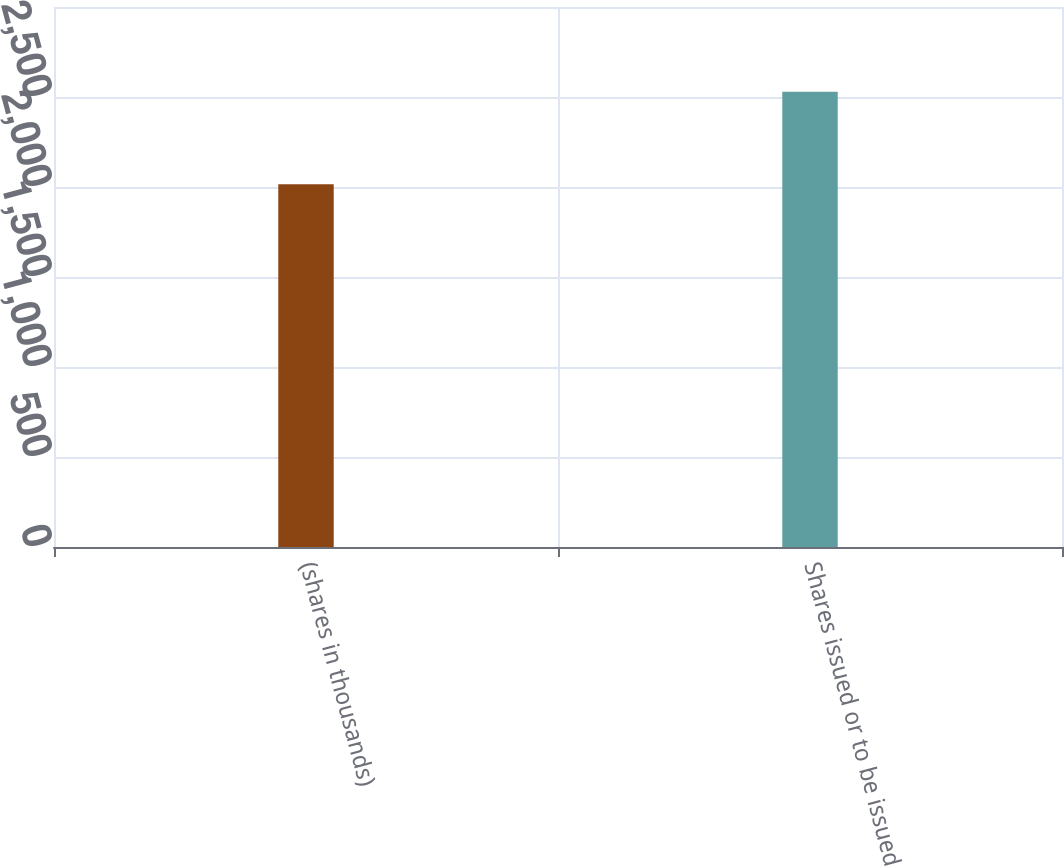Convert chart to OTSL. <chart><loc_0><loc_0><loc_500><loc_500><bar_chart><fcel>(shares in thousands)<fcel>Shares issued or to be issued<nl><fcel>2015<fcel>2529<nl></chart> 